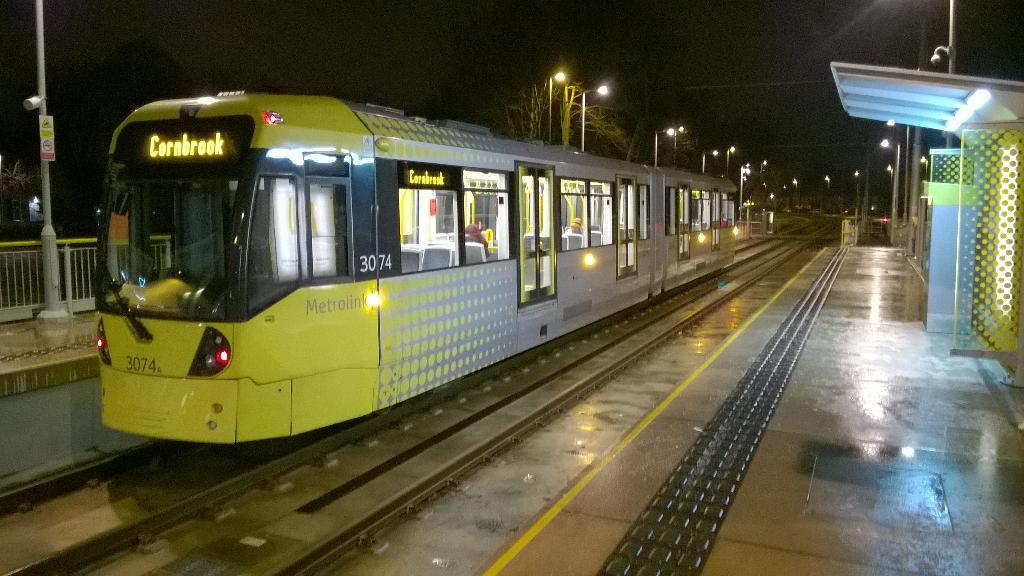<image>
Write a terse but informative summary of the picture. The train heading to Cornbrook has just arrived at a train station. 